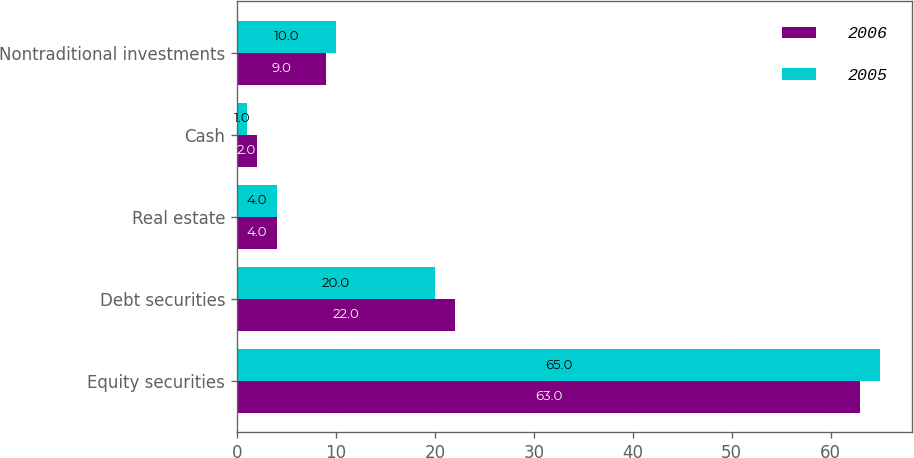<chart> <loc_0><loc_0><loc_500><loc_500><stacked_bar_chart><ecel><fcel>Equity securities<fcel>Debt securities<fcel>Real estate<fcel>Cash<fcel>Nontraditional investments<nl><fcel>2006<fcel>63<fcel>22<fcel>4<fcel>2<fcel>9<nl><fcel>2005<fcel>65<fcel>20<fcel>4<fcel>1<fcel>10<nl></chart> 